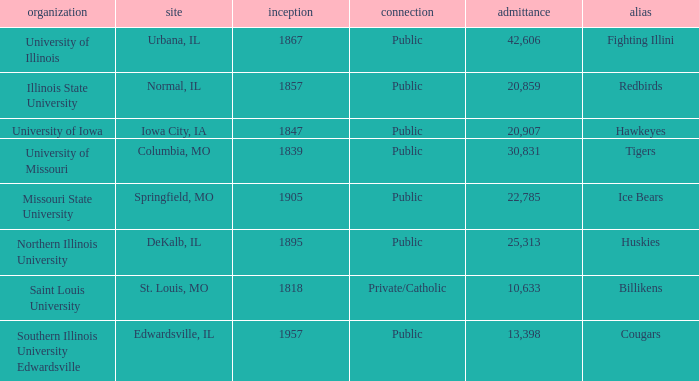What is the average enrollment of the Redbirds' school? 20859.0. 